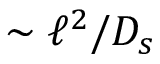<formula> <loc_0><loc_0><loc_500><loc_500>\sim \ell ^ { 2 } / D _ { s }</formula> 